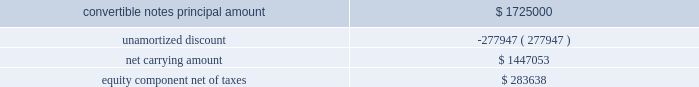Table of contents as of september 25 , 2010 , the carrying amount of the original notes and related equity component ( recorded in capital in excess of par value , net of deferred taxes ) consisted of the following: .
As noted above , on november 18 , 2010 , the company executed separate , privately-negotiated exchange agreements , and the company retired $ 450.0 million in aggregate principal of its original notes for $ 450.0 million in aggregate principal of exchange notes .
The company accounted for this retirement under the derecognition provisions of subtopic asc 470-20-40 , which requires the allocation of the fair value of the consideration transferred ( i.e. , the exchange notes ) between the liability and equity components of the original instrument to determine the gain or loss on the transaction .
In connection with this transaction , the company recorded a loss on extinguishment of debt of $ 29.9 million , which is comprised of the loss on the debt itself of $ 26.0 million and the write-off of the pro-rata amount of debt issuance costs of $ 3.9 million allocated to the notes retired .
The loss on the debt itself is calculated as the difference between the fair value of the liability component of the original notes 2019 amount retired immediately before the exchange and its related carrying value immediately before the exchange .
The fair value of the liability component was calculated similar to the description above for initially recording the original notes under fsp apb 14-1 , and the company used an effective interest rate of 5.46% ( 5.46 % ) , representing the estimated nonconvertible debt borrowing rate with a three year maturity at the measurement date .
In addition , under this accounting standard , a portion of the fair value of the consideration transferred is allocated to the reacquisition of the equity component , which is the difference between the fair value of the consideration transferred and the fair value of the liability component immediately before the exchange .
As a result , $ 39.9 million was allocated to the reacquisition of the equity component of the original instrument , which is recorded net of deferred taxes within capital in excess of par value .
Since the exchange notes have the same characteristics as the original notes and can be settled in cash or a combination of cash and shares of common stock ( i.e. , partial settlement ) , the company is required to account for the liability and equity components of its exchange notes separately to reflect its nonconvertible debt borrowing rate .
The company estimated the fair value of the exchange notes liability component to be $ 349.0 million using a discounted cash flow technique .
Key inputs used to estimate the fair value of the liability component included the company 2019s estimated nonconvertible debt borrowing rate as of november 18 , 2010 ( the date the convertible notes were issued ) , the amount and timing of cash flows , and the expected life of the exchange notes .
The company used an estimated effective interest rate of 6.52% ( 6.52 % ) .
The excess of the fair value transferred over the estimated fair value of the liability component totaling $ 97.3 million was allocated to the conversion feature as an increase to capital in excess of par value with a corresponding offset recognized as a discount to reduce the net carrying value of the exchange notes .
As a result of the fair value of the exchange notes being lower than the exchange notes principal value , there is an additional discount on the exchange notes of $ 3.7 million at the measurement date .
The total discount is being amortized to interest expense over a six-year period ending december 15 , 2016 ( the expected life of the liability component ) using the effective interest method .
In addition , third-party transaction costs have been allocated to the liability and equity components based on the relative values of these components .
Source : hologic inc , 10-k , november 23 , 2011 powered by morningstar ae document research 2120 the information contained herein may not be copied , adapted or distributed and is not warranted to be accurate , complete or timely .
The user assumes all risks for any damages or losses arising from any use of this information , except to the extent such damages or losses cannot be limited or excluded by applicable law .
Past financial performance is no guarantee of future results. .
What is the ratio of net carrying amount of notes to equity net of taxes? 
Computations: (1447053 / 283638)
Answer: 5.10176. 